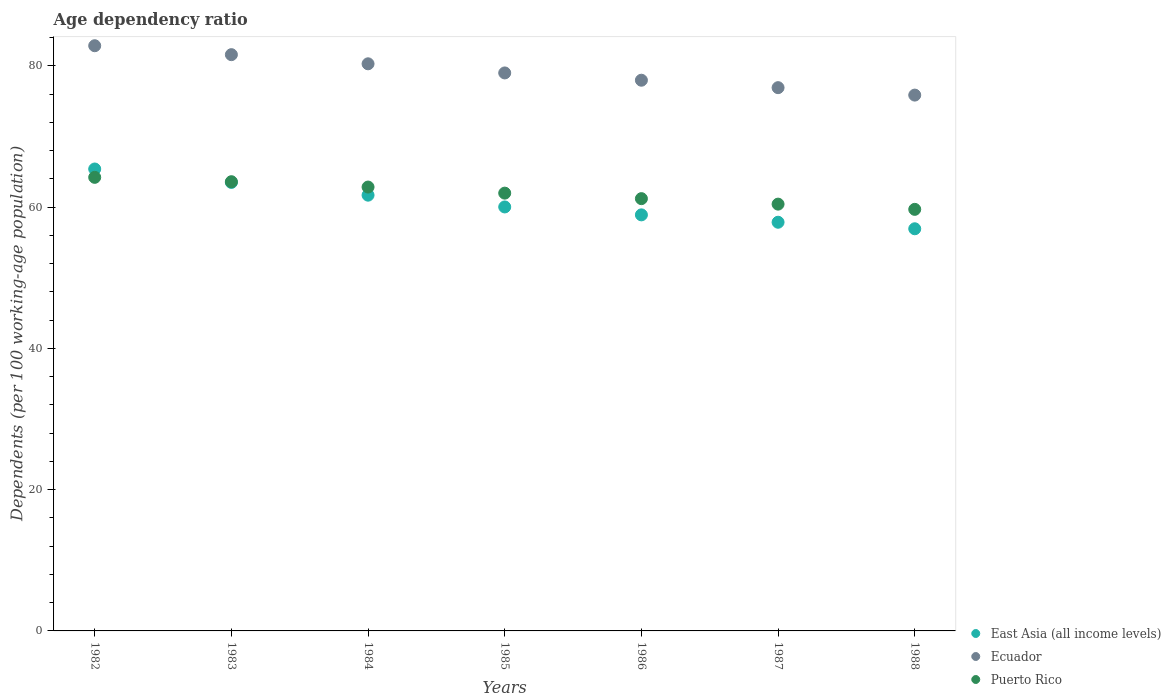What is the age dependency ratio in in Ecuador in 1987?
Provide a succinct answer. 76.91. Across all years, what is the maximum age dependency ratio in in Ecuador?
Ensure brevity in your answer.  82.85. Across all years, what is the minimum age dependency ratio in in Ecuador?
Provide a short and direct response. 75.86. In which year was the age dependency ratio in in Puerto Rico maximum?
Offer a terse response. 1982. In which year was the age dependency ratio in in Ecuador minimum?
Ensure brevity in your answer.  1988. What is the total age dependency ratio in in Ecuador in the graph?
Offer a terse response. 554.45. What is the difference between the age dependency ratio in in East Asia (all income levels) in 1985 and that in 1988?
Make the answer very short. 3.09. What is the difference between the age dependency ratio in in Ecuador in 1983 and the age dependency ratio in in Puerto Rico in 1987?
Ensure brevity in your answer.  21.16. What is the average age dependency ratio in in Puerto Rico per year?
Ensure brevity in your answer.  61.99. In the year 1983, what is the difference between the age dependency ratio in in East Asia (all income levels) and age dependency ratio in in Ecuador?
Ensure brevity in your answer.  -18.09. What is the ratio of the age dependency ratio in in East Asia (all income levels) in 1985 to that in 1987?
Ensure brevity in your answer.  1.04. Is the age dependency ratio in in Puerto Rico in 1983 less than that in 1987?
Provide a succinct answer. No. What is the difference between the highest and the second highest age dependency ratio in in Ecuador?
Give a very brief answer. 1.26. What is the difference between the highest and the lowest age dependency ratio in in Puerto Rico?
Ensure brevity in your answer.  4.53. Is the sum of the age dependency ratio in in Ecuador in 1984 and 1987 greater than the maximum age dependency ratio in in Puerto Rico across all years?
Give a very brief answer. Yes. Is the age dependency ratio in in Ecuador strictly greater than the age dependency ratio in in East Asia (all income levels) over the years?
Your response must be concise. Yes. Is the age dependency ratio in in Puerto Rico strictly less than the age dependency ratio in in Ecuador over the years?
Your answer should be very brief. Yes. How many years are there in the graph?
Your answer should be very brief. 7. What is the difference between two consecutive major ticks on the Y-axis?
Your answer should be compact. 20. Are the values on the major ticks of Y-axis written in scientific E-notation?
Keep it short and to the point. No. Where does the legend appear in the graph?
Ensure brevity in your answer.  Bottom right. What is the title of the graph?
Give a very brief answer. Age dependency ratio. What is the label or title of the X-axis?
Offer a very short reply. Years. What is the label or title of the Y-axis?
Ensure brevity in your answer.  Dependents (per 100 working-age population). What is the Dependents (per 100 working-age population) in East Asia (all income levels) in 1982?
Provide a short and direct response. 65.4. What is the Dependents (per 100 working-age population) of Ecuador in 1982?
Make the answer very short. 82.85. What is the Dependents (per 100 working-age population) in Puerto Rico in 1982?
Provide a succinct answer. 64.21. What is the Dependents (per 100 working-age population) in East Asia (all income levels) in 1983?
Give a very brief answer. 63.49. What is the Dependents (per 100 working-age population) of Ecuador in 1983?
Your response must be concise. 81.58. What is the Dependents (per 100 working-age population) of Puerto Rico in 1983?
Make the answer very short. 63.6. What is the Dependents (per 100 working-age population) in East Asia (all income levels) in 1984?
Give a very brief answer. 61.69. What is the Dependents (per 100 working-age population) of Ecuador in 1984?
Your response must be concise. 80.29. What is the Dependents (per 100 working-age population) of Puerto Rico in 1984?
Give a very brief answer. 62.84. What is the Dependents (per 100 working-age population) in East Asia (all income levels) in 1985?
Your response must be concise. 60.02. What is the Dependents (per 100 working-age population) of Ecuador in 1985?
Your answer should be compact. 79. What is the Dependents (per 100 working-age population) of Puerto Rico in 1985?
Offer a terse response. 61.98. What is the Dependents (per 100 working-age population) of East Asia (all income levels) in 1986?
Offer a terse response. 58.9. What is the Dependents (per 100 working-age population) of Ecuador in 1986?
Ensure brevity in your answer.  77.96. What is the Dependents (per 100 working-age population) of Puerto Rico in 1986?
Your response must be concise. 61.2. What is the Dependents (per 100 working-age population) of East Asia (all income levels) in 1987?
Your answer should be compact. 57.86. What is the Dependents (per 100 working-age population) in Ecuador in 1987?
Provide a short and direct response. 76.91. What is the Dependents (per 100 working-age population) of Puerto Rico in 1987?
Offer a terse response. 60.42. What is the Dependents (per 100 working-age population) in East Asia (all income levels) in 1988?
Offer a terse response. 56.93. What is the Dependents (per 100 working-age population) of Ecuador in 1988?
Provide a short and direct response. 75.86. What is the Dependents (per 100 working-age population) of Puerto Rico in 1988?
Offer a very short reply. 59.68. Across all years, what is the maximum Dependents (per 100 working-age population) in East Asia (all income levels)?
Give a very brief answer. 65.4. Across all years, what is the maximum Dependents (per 100 working-age population) of Ecuador?
Your response must be concise. 82.85. Across all years, what is the maximum Dependents (per 100 working-age population) of Puerto Rico?
Offer a very short reply. 64.21. Across all years, what is the minimum Dependents (per 100 working-age population) in East Asia (all income levels)?
Your response must be concise. 56.93. Across all years, what is the minimum Dependents (per 100 working-age population) in Ecuador?
Your answer should be compact. 75.86. Across all years, what is the minimum Dependents (per 100 working-age population) in Puerto Rico?
Provide a short and direct response. 59.68. What is the total Dependents (per 100 working-age population) of East Asia (all income levels) in the graph?
Keep it short and to the point. 424.3. What is the total Dependents (per 100 working-age population) of Ecuador in the graph?
Your answer should be compact. 554.45. What is the total Dependents (per 100 working-age population) in Puerto Rico in the graph?
Provide a succinct answer. 433.93. What is the difference between the Dependents (per 100 working-age population) in East Asia (all income levels) in 1982 and that in 1983?
Offer a terse response. 1.9. What is the difference between the Dependents (per 100 working-age population) of Ecuador in 1982 and that in 1983?
Your answer should be compact. 1.26. What is the difference between the Dependents (per 100 working-age population) in Puerto Rico in 1982 and that in 1983?
Your answer should be compact. 0.62. What is the difference between the Dependents (per 100 working-age population) of East Asia (all income levels) in 1982 and that in 1984?
Provide a succinct answer. 3.7. What is the difference between the Dependents (per 100 working-age population) of Ecuador in 1982 and that in 1984?
Provide a succinct answer. 2.56. What is the difference between the Dependents (per 100 working-age population) of Puerto Rico in 1982 and that in 1984?
Offer a very short reply. 1.37. What is the difference between the Dependents (per 100 working-age population) of East Asia (all income levels) in 1982 and that in 1985?
Your response must be concise. 5.37. What is the difference between the Dependents (per 100 working-age population) in Ecuador in 1982 and that in 1985?
Your response must be concise. 3.85. What is the difference between the Dependents (per 100 working-age population) in Puerto Rico in 1982 and that in 1985?
Offer a terse response. 2.24. What is the difference between the Dependents (per 100 working-age population) of East Asia (all income levels) in 1982 and that in 1986?
Provide a succinct answer. 6.49. What is the difference between the Dependents (per 100 working-age population) in Ecuador in 1982 and that in 1986?
Your response must be concise. 4.88. What is the difference between the Dependents (per 100 working-age population) of Puerto Rico in 1982 and that in 1986?
Offer a terse response. 3.02. What is the difference between the Dependents (per 100 working-age population) in East Asia (all income levels) in 1982 and that in 1987?
Make the answer very short. 7.54. What is the difference between the Dependents (per 100 working-age population) of Ecuador in 1982 and that in 1987?
Keep it short and to the point. 5.94. What is the difference between the Dependents (per 100 working-age population) in Puerto Rico in 1982 and that in 1987?
Give a very brief answer. 3.79. What is the difference between the Dependents (per 100 working-age population) of East Asia (all income levels) in 1982 and that in 1988?
Offer a very short reply. 8.46. What is the difference between the Dependents (per 100 working-age population) in Ecuador in 1982 and that in 1988?
Give a very brief answer. 6.99. What is the difference between the Dependents (per 100 working-age population) of Puerto Rico in 1982 and that in 1988?
Your response must be concise. 4.53. What is the difference between the Dependents (per 100 working-age population) in East Asia (all income levels) in 1983 and that in 1984?
Give a very brief answer. 1.8. What is the difference between the Dependents (per 100 working-age population) in Ecuador in 1983 and that in 1984?
Provide a succinct answer. 1.3. What is the difference between the Dependents (per 100 working-age population) of Puerto Rico in 1983 and that in 1984?
Offer a very short reply. 0.76. What is the difference between the Dependents (per 100 working-age population) of East Asia (all income levels) in 1983 and that in 1985?
Provide a succinct answer. 3.47. What is the difference between the Dependents (per 100 working-age population) in Ecuador in 1983 and that in 1985?
Provide a short and direct response. 2.59. What is the difference between the Dependents (per 100 working-age population) in Puerto Rico in 1983 and that in 1985?
Your answer should be very brief. 1.62. What is the difference between the Dependents (per 100 working-age population) of East Asia (all income levels) in 1983 and that in 1986?
Your answer should be compact. 4.59. What is the difference between the Dependents (per 100 working-age population) of Ecuador in 1983 and that in 1986?
Your answer should be compact. 3.62. What is the difference between the Dependents (per 100 working-age population) of Puerto Rico in 1983 and that in 1986?
Your answer should be very brief. 2.4. What is the difference between the Dependents (per 100 working-age population) of East Asia (all income levels) in 1983 and that in 1987?
Make the answer very short. 5.64. What is the difference between the Dependents (per 100 working-age population) in Ecuador in 1983 and that in 1987?
Ensure brevity in your answer.  4.67. What is the difference between the Dependents (per 100 working-age population) of Puerto Rico in 1983 and that in 1987?
Make the answer very short. 3.17. What is the difference between the Dependents (per 100 working-age population) in East Asia (all income levels) in 1983 and that in 1988?
Your answer should be very brief. 6.56. What is the difference between the Dependents (per 100 working-age population) in Ecuador in 1983 and that in 1988?
Your answer should be very brief. 5.72. What is the difference between the Dependents (per 100 working-age population) of Puerto Rico in 1983 and that in 1988?
Ensure brevity in your answer.  3.91. What is the difference between the Dependents (per 100 working-age population) of East Asia (all income levels) in 1984 and that in 1985?
Your answer should be very brief. 1.67. What is the difference between the Dependents (per 100 working-age population) of Ecuador in 1984 and that in 1985?
Your answer should be very brief. 1.29. What is the difference between the Dependents (per 100 working-age population) in Puerto Rico in 1984 and that in 1985?
Provide a short and direct response. 0.86. What is the difference between the Dependents (per 100 working-age population) in East Asia (all income levels) in 1984 and that in 1986?
Your answer should be very brief. 2.79. What is the difference between the Dependents (per 100 working-age population) in Ecuador in 1984 and that in 1986?
Ensure brevity in your answer.  2.32. What is the difference between the Dependents (per 100 working-age population) of Puerto Rico in 1984 and that in 1986?
Make the answer very short. 1.64. What is the difference between the Dependents (per 100 working-age population) in East Asia (all income levels) in 1984 and that in 1987?
Your answer should be very brief. 3.83. What is the difference between the Dependents (per 100 working-age population) in Ecuador in 1984 and that in 1987?
Ensure brevity in your answer.  3.38. What is the difference between the Dependents (per 100 working-age population) of Puerto Rico in 1984 and that in 1987?
Offer a terse response. 2.42. What is the difference between the Dependents (per 100 working-age population) of East Asia (all income levels) in 1984 and that in 1988?
Offer a very short reply. 4.76. What is the difference between the Dependents (per 100 working-age population) in Ecuador in 1984 and that in 1988?
Provide a succinct answer. 4.43. What is the difference between the Dependents (per 100 working-age population) in Puerto Rico in 1984 and that in 1988?
Your answer should be very brief. 3.16. What is the difference between the Dependents (per 100 working-age population) of East Asia (all income levels) in 1985 and that in 1986?
Provide a succinct answer. 1.12. What is the difference between the Dependents (per 100 working-age population) in Ecuador in 1985 and that in 1986?
Provide a succinct answer. 1.03. What is the difference between the Dependents (per 100 working-age population) in Puerto Rico in 1985 and that in 1986?
Ensure brevity in your answer.  0.78. What is the difference between the Dependents (per 100 working-age population) in East Asia (all income levels) in 1985 and that in 1987?
Offer a terse response. 2.17. What is the difference between the Dependents (per 100 working-age population) of Ecuador in 1985 and that in 1987?
Your response must be concise. 2.08. What is the difference between the Dependents (per 100 working-age population) in Puerto Rico in 1985 and that in 1987?
Offer a terse response. 1.56. What is the difference between the Dependents (per 100 working-age population) in East Asia (all income levels) in 1985 and that in 1988?
Give a very brief answer. 3.09. What is the difference between the Dependents (per 100 working-age population) of Ecuador in 1985 and that in 1988?
Provide a short and direct response. 3.14. What is the difference between the Dependents (per 100 working-age population) in Puerto Rico in 1985 and that in 1988?
Keep it short and to the point. 2.3. What is the difference between the Dependents (per 100 working-age population) of East Asia (all income levels) in 1986 and that in 1987?
Offer a terse response. 1.05. What is the difference between the Dependents (per 100 working-age population) of Ecuador in 1986 and that in 1987?
Give a very brief answer. 1.05. What is the difference between the Dependents (per 100 working-age population) of Puerto Rico in 1986 and that in 1987?
Provide a succinct answer. 0.78. What is the difference between the Dependents (per 100 working-age population) of East Asia (all income levels) in 1986 and that in 1988?
Your answer should be compact. 1.97. What is the difference between the Dependents (per 100 working-age population) of Ecuador in 1986 and that in 1988?
Provide a short and direct response. 2.11. What is the difference between the Dependents (per 100 working-age population) in Puerto Rico in 1986 and that in 1988?
Offer a terse response. 1.52. What is the difference between the Dependents (per 100 working-age population) in East Asia (all income levels) in 1987 and that in 1988?
Keep it short and to the point. 0.92. What is the difference between the Dependents (per 100 working-age population) of Ecuador in 1987 and that in 1988?
Offer a terse response. 1.05. What is the difference between the Dependents (per 100 working-age population) in Puerto Rico in 1987 and that in 1988?
Offer a very short reply. 0.74. What is the difference between the Dependents (per 100 working-age population) of East Asia (all income levels) in 1982 and the Dependents (per 100 working-age population) of Ecuador in 1983?
Make the answer very short. -16.19. What is the difference between the Dependents (per 100 working-age population) in East Asia (all income levels) in 1982 and the Dependents (per 100 working-age population) in Puerto Rico in 1983?
Give a very brief answer. 1.8. What is the difference between the Dependents (per 100 working-age population) in Ecuador in 1982 and the Dependents (per 100 working-age population) in Puerto Rico in 1983?
Ensure brevity in your answer.  19.25. What is the difference between the Dependents (per 100 working-age population) in East Asia (all income levels) in 1982 and the Dependents (per 100 working-age population) in Ecuador in 1984?
Your response must be concise. -14.89. What is the difference between the Dependents (per 100 working-age population) in East Asia (all income levels) in 1982 and the Dependents (per 100 working-age population) in Puerto Rico in 1984?
Ensure brevity in your answer.  2.56. What is the difference between the Dependents (per 100 working-age population) in Ecuador in 1982 and the Dependents (per 100 working-age population) in Puerto Rico in 1984?
Your answer should be very brief. 20.01. What is the difference between the Dependents (per 100 working-age population) of East Asia (all income levels) in 1982 and the Dependents (per 100 working-age population) of Ecuador in 1985?
Make the answer very short. -13.6. What is the difference between the Dependents (per 100 working-age population) of East Asia (all income levels) in 1982 and the Dependents (per 100 working-age population) of Puerto Rico in 1985?
Provide a short and direct response. 3.42. What is the difference between the Dependents (per 100 working-age population) of Ecuador in 1982 and the Dependents (per 100 working-age population) of Puerto Rico in 1985?
Your answer should be very brief. 20.87. What is the difference between the Dependents (per 100 working-age population) of East Asia (all income levels) in 1982 and the Dependents (per 100 working-age population) of Ecuador in 1986?
Your response must be concise. -12.57. What is the difference between the Dependents (per 100 working-age population) in East Asia (all income levels) in 1982 and the Dependents (per 100 working-age population) in Puerto Rico in 1986?
Offer a terse response. 4.2. What is the difference between the Dependents (per 100 working-age population) in Ecuador in 1982 and the Dependents (per 100 working-age population) in Puerto Rico in 1986?
Ensure brevity in your answer.  21.65. What is the difference between the Dependents (per 100 working-age population) in East Asia (all income levels) in 1982 and the Dependents (per 100 working-age population) in Ecuador in 1987?
Give a very brief answer. -11.52. What is the difference between the Dependents (per 100 working-age population) of East Asia (all income levels) in 1982 and the Dependents (per 100 working-age population) of Puerto Rico in 1987?
Your answer should be compact. 4.97. What is the difference between the Dependents (per 100 working-age population) in Ecuador in 1982 and the Dependents (per 100 working-age population) in Puerto Rico in 1987?
Give a very brief answer. 22.43. What is the difference between the Dependents (per 100 working-age population) in East Asia (all income levels) in 1982 and the Dependents (per 100 working-age population) in Ecuador in 1988?
Your answer should be very brief. -10.46. What is the difference between the Dependents (per 100 working-age population) of East Asia (all income levels) in 1982 and the Dependents (per 100 working-age population) of Puerto Rico in 1988?
Your answer should be very brief. 5.71. What is the difference between the Dependents (per 100 working-age population) in Ecuador in 1982 and the Dependents (per 100 working-age population) in Puerto Rico in 1988?
Offer a terse response. 23.17. What is the difference between the Dependents (per 100 working-age population) of East Asia (all income levels) in 1983 and the Dependents (per 100 working-age population) of Ecuador in 1984?
Your answer should be very brief. -16.79. What is the difference between the Dependents (per 100 working-age population) in East Asia (all income levels) in 1983 and the Dependents (per 100 working-age population) in Puerto Rico in 1984?
Your response must be concise. 0.65. What is the difference between the Dependents (per 100 working-age population) of Ecuador in 1983 and the Dependents (per 100 working-age population) of Puerto Rico in 1984?
Offer a terse response. 18.74. What is the difference between the Dependents (per 100 working-age population) in East Asia (all income levels) in 1983 and the Dependents (per 100 working-age population) in Ecuador in 1985?
Keep it short and to the point. -15.5. What is the difference between the Dependents (per 100 working-age population) of East Asia (all income levels) in 1983 and the Dependents (per 100 working-age population) of Puerto Rico in 1985?
Your answer should be compact. 1.52. What is the difference between the Dependents (per 100 working-age population) in Ecuador in 1983 and the Dependents (per 100 working-age population) in Puerto Rico in 1985?
Ensure brevity in your answer.  19.6. What is the difference between the Dependents (per 100 working-age population) of East Asia (all income levels) in 1983 and the Dependents (per 100 working-age population) of Ecuador in 1986?
Your answer should be compact. -14.47. What is the difference between the Dependents (per 100 working-age population) of East Asia (all income levels) in 1983 and the Dependents (per 100 working-age population) of Puerto Rico in 1986?
Keep it short and to the point. 2.3. What is the difference between the Dependents (per 100 working-age population) in Ecuador in 1983 and the Dependents (per 100 working-age population) in Puerto Rico in 1986?
Provide a short and direct response. 20.38. What is the difference between the Dependents (per 100 working-age population) in East Asia (all income levels) in 1983 and the Dependents (per 100 working-age population) in Ecuador in 1987?
Make the answer very short. -13.42. What is the difference between the Dependents (per 100 working-age population) of East Asia (all income levels) in 1983 and the Dependents (per 100 working-age population) of Puerto Rico in 1987?
Your answer should be compact. 3.07. What is the difference between the Dependents (per 100 working-age population) of Ecuador in 1983 and the Dependents (per 100 working-age population) of Puerto Rico in 1987?
Your answer should be compact. 21.16. What is the difference between the Dependents (per 100 working-age population) in East Asia (all income levels) in 1983 and the Dependents (per 100 working-age population) in Ecuador in 1988?
Keep it short and to the point. -12.36. What is the difference between the Dependents (per 100 working-age population) of East Asia (all income levels) in 1983 and the Dependents (per 100 working-age population) of Puerto Rico in 1988?
Provide a succinct answer. 3.81. What is the difference between the Dependents (per 100 working-age population) of Ecuador in 1983 and the Dependents (per 100 working-age population) of Puerto Rico in 1988?
Keep it short and to the point. 21.9. What is the difference between the Dependents (per 100 working-age population) in East Asia (all income levels) in 1984 and the Dependents (per 100 working-age population) in Ecuador in 1985?
Make the answer very short. -17.3. What is the difference between the Dependents (per 100 working-age population) of East Asia (all income levels) in 1984 and the Dependents (per 100 working-age population) of Puerto Rico in 1985?
Give a very brief answer. -0.29. What is the difference between the Dependents (per 100 working-age population) in Ecuador in 1984 and the Dependents (per 100 working-age population) in Puerto Rico in 1985?
Your answer should be very brief. 18.31. What is the difference between the Dependents (per 100 working-age population) in East Asia (all income levels) in 1984 and the Dependents (per 100 working-age population) in Ecuador in 1986?
Offer a very short reply. -16.27. What is the difference between the Dependents (per 100 working-age population) in East Asia (all income levels) in 1984 and the Dependents (per 100 working-age population) in Puerto Rico in 1986?
Make the answer very short. 0.49. What is the difference between the Dependents (per 100 working-age population) in Ecuador in 1984 and the Dependents (per 100 working-age population) in Puerto Rico in 1986?
Your answer should be compact. 19.09. What is the difference between the Dependents (per 100 working-age population) in East Asia (all income levels) in 1984 and the Dependents (per 100 working-age population) in Ecuador in 1987?
Your answer should be very brief. -15.22. What is the difference between the Dependents (per 100 working-age population) of East Asia (all income levels) in 1984 and the Dependents (per 100 working-age population) of Puerto Rico in 1987?
Keep it short and to the point. 1.27. What is the difference between the Dependents (per 100 working-age population) of Ecuador in 1984 and the Dependents (per 100 working-age population) of Puerto Rico in 1987?
Give a very brief answer. 19.87. What is the difference between the Dependents (per 100 working-age population) in East Asia (all income levels) in 1984 and the Dependents (per 100 working-age population) in Ecuador in 1988?
Offer a very short reply. -14.17. What is the difference between the Dependents (per 100 working-age population) of East Asia (all income levels) in 1984 and the Dependents (per 100 working-age population) of Puerto Rico in 1988?
Your response must be concise. 2.01. What is the difference between the Dependents (per 100 working-age population) in Ecuador in 1984 and the Dependents (per 100 working-age population) in Puerto Rico in 1988?
Your response must be concise. 20.61. What is the difference between the Dependents (per 100 working-age population) in East Asia (all income levels) in 1985 and the Dependents (per 100 working-age population) in Ecuador in 1986?
Give a very brief answer. -17.94. What is the difference between the Dependents (per 100 working-age population) of East Asia (all income levels) in 1985 and the Dependents (per 100 working-age population) of Puerto Rico in 1986?
Keep it short and to the point. -1.17. What is the difference between the Dependents (per 100 working-age population) in Ecuador in 1985 and the Dependents (per 100 working-age population) in Puerto Rico in 1986?
Offer a very short reply. 17.8. What is the difference between the Dependents (per 100 working-age population) in East Asia (all income levels) in 1985 and the Dependents (per 100 working-age population) in Ecuador in 1987?
Your answer should be very brief. -16.89. What is the difference between the Dependents (per 100 working-age population) in East Asia (all income levels) in 1985 and the Dependents (per 100 working-age population) in Puerto Rico in 1987?
Offer a very short reply. -0.4. What is the difference between the Dependents (per 100 working-age population) in Ecuador in 1985 and the Dependents (per 100 working-age population) in Puerto Rico in 1987?
Your answer should be very brief. 18.57. What is the difference between the Dependents (per 100 working-age population) of East Asia (all income levels) in 1985 and the Dependents (per 100 working-age population) of Ecuador in 1988?
Your answer should be compact. -15.84. What is the difference between the Dependents (per 100 working-age population) of East Asia (all income levels) in 1985 and the Dependents (per 100 working-age population) of Puerto Rico in 1988?
Provide a succinct answer. 0.34. What is the difference between the Dependents (per 100 working-age population) in Ecuador in 1985 and the Dependents (per 100 working-age population) in Puerto Rico in 1988?
Offer a very short reply. 19.31. What is the difference between the Dependents (per 100 working-age population) of East Asia (all income levels) in 1986 and the Dependents (per 100 working-age population) of Ecuador in 1987?
Give a very brief answer. -18.01. What is the difference between the Dependents (per 100 working-age population) in East Asia (all income levels) in 1986 and the Dependents (per 100 working-age population) in Puerto Rico in 1987?
Offer a very short reply. -1.52. What is the difference between the Dependents (per 100 working-age population) in Ecuador in 1986 and the Dependents (per 100 working-age population) in Puerto Rico in 1987?
Provide a short and direct response. 17.54. What is the difference between the Dependents (per 100 working-age population) of East Asia (all income levels) in 1986 and the Dependents (per 100 working-age population) of Ecuador in 1988?
Provide a short and direct response. -16.96. What is the difference between the Dependents (per 100 working-age population) in East Asia (all income levels) in 1986 and the Dependents (per 100 working-age population) in Puerto Rico in 1988?
Your answer should be very brief. -0.78. What is the difference between the Dependents (per 100 working-age population) of Ecuador in 1986 and the Dependents (per 100 working-age population) of Puerto Rico in 1988?
Provide a short and direct response. 18.28. What is the difference between the Dependents (per 100 working-age population) of East Asia (all income levels) in 1987 and the Dependents (per 100 working-age population) of Ecuador in 1988?
Offer a very short reply. -18. What is the difference between the Dependents (per 100 working-age population) of East Asia (all income levels) in 1987 and the Dependents (per 100 working-age population) of Puerto Rico in 1988?
Your answer should be very brief. -1.82. What is the difference between the Dependents (per 100 working-age population) in Ecuador in 1987 and the Dependents (per 100 working-age population) in Puerto Rico in 1988?
Provide a succinct answer. 17.23. What is the average Dependents (per 100 working-age population) of East Asia (all income levels) per year?
Provide a succinct answer. 60.61. What is the average Dependents (per 100 working-age population) of Ecuador per year?
Provide a short and direct response. 79.21. What is the average Dependents (per 100 working-age population) in Puerto Rico per year?
Offer a terse response. 61.99. In the year 1982, what is the difference between the Dependents (per 100 working-age population) of East Asia (all income levels) and Dependents (per 100 working-age population) of Ecuador?
Provide a short and direct response. -17.45. In the year 1982, what is the difference between the Dependents (per 100 working-age population) in East Asia (all income levels) and Dependents (per 100 working-age population) in Puerto Rico?
Your answer should be compact. 1.18. In the year 1982, what is the difference between the Dependents (per 100 working-age population) of Ecuador and Dependents (per 100 working-age population) of Puerto Rico?
Ensure brevity in your answer.  18.63. In the year 1983, what is the difference between the Dependents (per 100 working-age population) of East Asia (all income levels) and Dependents (per 100 working-age population) of Ecuador?
Give a very brief answer. -18.09. In the year 1983, what is the difference between the Dependents (per 100 working-age population) in East Asia (all income levels) and Dependents (per 100 working-age population) in Puerto Rico?
Your answer should be very brief. -0.1. In the year 1983, what is the difference between the Dependents (per 100 working-age population) in Ecuador and Dependents (per 100 working-age population) in Puerto Rico?
Your response must be concise. 17.99. In the year 1984, what is the difference between the Dependents (per 100 working-age population) of East Asia (all income levels) and Dependents (per 100 working-age population) of Ecuador?
Offer a very short reply. -18.6. In the year 1984, what is the difference between the Dependents (per 100 working-age population) of East Asia (all income levels) and Dependents (per 100 working-age population) of Puerto Rico?
Provide a short and direct response. -1.15. In the year 1984, what is the difference between the Dependents (per 100 working-age population) of Ecuador and Dependents (per 100 working-age population) of Puerto Rico?
Keep it short and to the point. 17.45. In the year 1985, what is the difference between the Dependents (per 100 working-age population) in East Asia (all income levels) and Dependents (per 100 working-age population) in Ecuador?
Your response must be concise. -18.97. In the year 1985, what is the difference between the Dependents (per 100 working-age population) of East Asia (all income levels) and Dependents (per 100 working-age population) of Puerto Rico?
Ensure brevity in your answer.  -1.95. In the year 1985, what is the difference between the Dependents (per 100 working-age population) of Ecuador and Dependents (per 100 working-age population) of Puerto Rico?
Provide a short and direct response. 17.02. In the year 1986, what is the difference between the Dependents (per 100 working-age population) in East Asia (all income levels) and Dependents (per 100 working-age population) in Ecuador?
Your response must be concise. -19.06. In the year 1986, what is the difference between the Dependents (per 100 working-age population) of East Asia (all income levels) and Dependents (per 100 working-age population) of Puerto Rico?
Your answer should be very brief. -2.3. In the year 1986, what is the difference between the Dependents (per 100 working-age population) of Ecuador and Dependents (per 100 working-age population) of Puerto Rico?
Your answer should be very brief. 16.77. In the year 1987, what is the difference between the Dependents (per 100 working-age population) of East Asia (all income levels) and Dependents (per 100 working-age population) of Ecuador?
Make the answer very short. -19.05. In the year 1987, what is the difference between the Dependents (per 100 working-age population) in East Asia (all income levels) and Dependents (per 100 working-age population) in Puerto Rico?
Provide a succinct answer. -2.57. In the year 1987, what is the difference between the Dependents (per 100 working-age population) of Ecuador and Dependents (per 100 working-age population) of Puerto Rico?
Your response must be concise. 16.49. In the year 1988, what is the difference between the Dependents (per 100 working-age population) in East Asia (all income levels) and Dependents (per 100 working-age population) in Ecuador?
Your answer should be very brief. -18.93. In the year 1988, what is the difference between the Dependents (per 100 working-age population) of East Asia (all income levels) and Dependents (per 100 working-age population) of Puerto Rico?
Give a very brief answer. -2.75. In the year 1988, what is the difference between the Dependents (per 100 working-age population) of Ecuador and Dependents (per 100 working-age population) of Puerto Rico?
Provide a succinct answer. 16.18. What is the ratio of the Dependents (per 100 working-age population) in Ecuador in 1982 to that in 1983?
Make the answer very short. 1.02. What is the ratio of the Dependents (per 100 working-age population) of Puerto Rico in 1982 to that in 1983?
Give a very brief answer. 1.01. What is the ratio of the Dependents (per 100 working-age population) in East Asia (all income levels) in 1982 to that in 1984?
Your answer should be very brief. 1.06. What is the ratio of the Dependents (per 100 working-age population) in Ecuador in 1982 to that in 1984?
Provide a short and direct response. 1.03. What is the ratio of the Dependents (per 100 working-age population) of Puerto Rico in 1982 to that in 1984?
Ensure brevity in your answer.  1.02. What is the ratio of the Dependents (per 100 working-age population) of East Asia (all income levels) in 1982 to that in 1985?
Your answer should be compact. 1.09. What is the ratio of the Dependents (per 100 working-age population) in Ecuador in 1982 to that in 1985?
Your response must be concise. 1.05. What is the ratio of the Dependents (per 100 working-age population) in Puerto Rico in 1982 to that in 1985?
Ensure brevity in your answer.  1.04. What is the ratio of the Dependents (per 100 working-age population) of East Asia (all income levels) in 1982 to that in 1986?
Make the answer very short. 1.11. What is the ratio of the Dependents (per 100 working-age population) in Ecuador in 1982 to that in 1986?
Your response must be concise. 1.06. What is the ratio of the Dependents (per 100 working-age population) in Puerto Rico in 1982 to that in 1986?
Provide a succinct answer. 1.05. What is the ratio of the Dependents (per 100 working-age population) in East Asia (all income levels) in 1982 to that in 1987?
Your answer should be compact. 1.13. What is the ratio of the Dependents (per 100 working-age population) in Ecuador in 1982 to that in 1987?
Ensure brevity in your answer.  1.08. What is the ratio of the Dependents (per 100 working-age population) in Puerto Rico in 1982 to that in 1987?
Give a very brief answer. 1.06. What is the ratio of the Dependents (per 100 working-age population) in East Asia (all income levels) in 1982 to that in 1988?
Give a very brief answer. 1.15. What is the ratio of the Dependents (per 100 working-age population) of Ecuador in 1982 to that in 1988?
Provide a short and direct response. 1.09. What is the ratio of the Dependents (per 100 working-age population) of Puerto Rico in 1982 to that in 1988?
Provide a short and direct response. 1.08. What is the ratio of the Dependents (per 100 working-age population) of East Asia (all income levels) in 1983 to that in 1984?
Ensure brevity in your answer.  1.03. What is the ratio of the Dependents (per 100 working-age population) of Ecuador in 1983 to that in 1984?
Offer a terse response. 1.02. What is the ratio of the Dependents (per 100 working-age population) of Puerto Rico in 1983 to that in 1984?
Offer a terse response. 1.01. What is the ratio of the Dependents (per 100 working-age population) in East Asia (all income levels) in 1983 to that in 1985?
Provide a succinct answer. 1.06. What is the ratio of the Dependents (per 100 working-age population) of Ecuador in 1983 to that in 1985?
Your response must be concise. 1.03. What is the ratio of the Dependents (per 100 working-age population) in Puerto Rico in 1983 to that in 1985?
Make the answer very short. 1.03. What is the ratio of the Dependents (per 100 working-age population) in East Asia (all income levels) in 1983 to that in 1986?
Your response must be concise. 1.08. What is the ratio of the Dependents (per 100 working-age population) in Ecuador in 1983 to that in 1986?
Offer a terse response. 1.05. What is the ratio of the Dependents (per 100 working-age population) of Puerto Rico in 1983 to that in 1986?
Your answer should be compact. 1.04. What is the ratio of the Dependents (per 100 working-age population) in East Asia (all income levels) in 1983 to that in 1987?
Offer a very short reply. 1.1. What is the ratio of the Dependents (per 100 working-age population) in Ecuador in 1983 to that in 1987?
Your answer should be compact. 1.06. What is the ratio of the Dependents (per 100 working-age population) of Puerto Rico in 1983 to that in 1987?
Give a very brief answer. 1.05. What is the ratio of the Dependents (per 100 working-age population) of East Asia (all income levels) in 1983 to that in 1988?
Provide a succinct answer. 1.12. What is the ratio of the Dependents (per 100 working-age population) in Ecuador in 1983 to that in 1988?
Offer a terse response. 1.08. What is the ratio of the Dependents (per 100 working-age population) in Puerto Rico in 1983 to that in 1988?
Offer a very short reply. 1.07. What is the ratio of the Dependents (per 100 working-age population) of East Asia (all income levels) in 1984 to that in 1985?
Keep it short and to the point. 1.03. What is the ratio of the Dependents (per 100 working-age population) of Ecuador in 1984 to that in 1985?
Offer a very short reply. 1.02. What is the ratio of the Dependents (per 100 working-age population) in Puerto Rico in 1984 to that in 1985?
Keep it short and to the point. 1.01. What is the ratio of the Dependents (per 100 working-age population) of East Asia (all income levels) in 1984 to that in 1986?
Provide a succinct answer. 1.05. What is the ratio of the Dependents (per 100 working-age population) of Ecuador in 1984 to that in 1986?
Offer a terse response. 1.03. What is the ratio of the Dependents (per 100 working-age population) in Puerto Rico in 1984 to that in 1986?
Give a very brief answer. 1.03. What is the ratio of the Dependents (per 100 working-age population) of East Asia (all income levels) in 1984 to that in 1987?
Give a very brief answer. 1.07. What is the ratio of the Dependents (per 100 working-age population) of Ecuador in 1984 to that in 1987?
Keep it short and to the point. 1.04. What is the ratio of the Dependents (per 100 working-age population) in East Asia (all income levels) in 1984 to that in 1988?
Ensure brevity in your answer.  1.08. What is the ratio of the Dependents (per 100 working-age population) of Ecuador in 1984 to that in 1988?
Offer a very short reply. 1.06. What is the ratio of the Dependents (per 100 working-age population) of Puerto Rico in 1984 to that in 1988?
Your answer should be compact. 1.05. What is the ratio of the Dependents (per 100 working-age population) in Ecuador in 1985 to that in 1986?
Offer a terse response. 1.01. What is the ratio of the Dependents (per 100 working-age population) of Puerto Rico in 1985 to that in 1986?
Keep it short and to the point. 1.01. What is the ratio of the Dependents (per 100 working-age population) of East Asia (all income levels) in 1985 to that in 1987?
Provide a short and direct response. 1.04. What is the ratio of the Dependents (per 100 working-age population) in Ecuador in 1985 to that in 1987?
Your answer should be compact. 1.03. What is the ratio of the Dependents (per 100 working-age population) of Puerto Rico in 1985 to that in 1987?
Your response must be concise. 1.03. What is the ratio of the Dependents (per 100 working-age population) of East Asia (all income levels) in 1985 to that in 1988?
Your response must be concise. 1.05. What is the ratio of the Dependents (per 100 working-age population) of Ecuador in 1985 to that in 1988?
Make the answer very short. 1.04. What is the ratio of the Dependents (per 100 working-age population) in Puerto Rico in 1985 to that in 1988?
Give a very brief answer. 1.04. What is the ratio of the Dependents (per 100 working-age population) of East Asia (all income levels) in 1986 to that in 1987?
Offer a very short reply. 1.02. What is the ratio of the Dependents (per 100 working-age population) of Ecuador in 1986 to that in 1987?
Keep it short and to the point. 1.01. What is the ratio of the Dependents (per 100 working-age population) in Puerto Rico in 1986 to that in 1987?
Ensure brevity in your answer.  1.01. What is the ratio of the Dependents (per 100 working-age population) of East Asia (all income levels) in 1986 to that in 1988?
Keep it short and to the point. 1.03. What is the ratio of the Dependents (per 100 working-age population) in Ecuador in 1986 to that in 1988?
Offer a very short reply. 1.03. What is the ratio of the Dependents (per 100 working-age population) of Puerto Rico in 1986 to that in 1988?
Keep it short and to the point. 1.03. What is the ratio of the Dependents (per 100 working-age population) of East Asia (all income levels) in 1987 to that in 1988?
Offer a very short reply. 1.02. What is the ratio of the Dependents (per 100 working-age population) of Ecuador in 1987 to that in 1988?
Keep it short and to the point. 1.01. What is the ratio of the Dependents (per 100 working-age population) in Puerto Rico in 1987 to that in 1988?
Make the answer very short. 1.01. What is the difference between the highest and the second highest Dependents (per 100 working-age population) of East Asia (all income levels)?
Provide a short and direct response. 1.9. What is the difference between the highest and the second highest Dependents (per 100 working-age population) in Ecuador?
Offer a very short reply. 1.26. What is the difference between the highest and the second highest Dependents (per 100 working-age population) of Puerto Rico?
Offer a very short reply. 0.62. What is the difference between the highest and the lowest Dependents (per 100 working-age population) of East Asia (all income levels)?
Offer a very short reply. 8.46. What is the difference between the highest and the lowest Dependents (per 100 working-age population) of Ecuador?
Your response must be concise. 6.99. What is the difference between the highest and the lowest Dependents (per 100 working-age population) in Puerto Rico?
Your response must be concise. 4.53. 